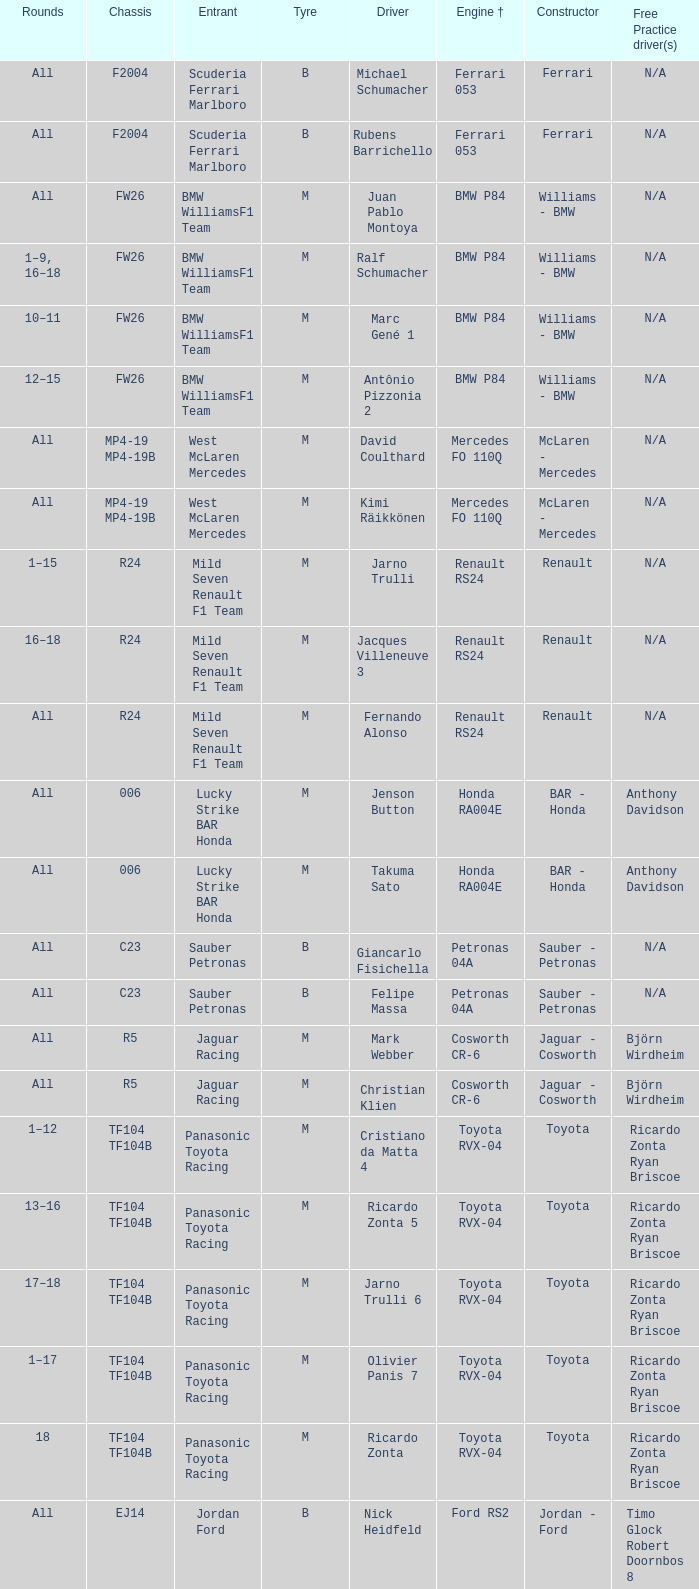Could you parse the entire table? {'header': ['Rounds', 'Chassis', 'Entrant', 'Tyre', 'Driver', 'Engine †', 'Constructor', 'Free Practice driver(s)'], 'rows': [['All', 'F2004', 'Scuderia Ferrari Marlboro', 'B', 'Michael Schumacher', 'Ferrari 053', 'Ferrari', 'N/A'], ['All', 'F2004', 'Scuderia Ferrari Marlboro', 'B', 'Rubens Barrichello', 'Ferrari 053', 'Ferrari', 'N/A'], ['All', 'FW26', 'BMW WilliamsF1 Team', 'M', 'Juan Pablo Montoya', 'BMW P84', 'Williams - BMW', 'N/A'], ['1–9, 16–18', 'FW26', 'BMW WilliamsF1 Team', 'M', 'Ralf Schumacher', 'BMW P84', 'Williams - BMW', 'N/A'], ['10–11', 'FW26', 'BMW WilliamsF1 Team', 'M', 'Marc Gené 1', 'BMW P84', 'Williams - BMW', 'N/A'], ['12–15', 'FW26', 'BMW WilliamsF1 Team', 'M', 'Antônio Pizzonia 2', 'BMW P84', 'Williams - BMW', 'N/A'], ['All', 'MP4-19 MP4-19B', 'West McLaren Mercedes', 'M', 'David Coulthard', 'Mercedes FO 110Q', 'McLaren - Mercedes', 'N/A'], ['All', 'MP4-19 MP4-19B', 'West McLaren Mercedes', 'M', 'Kimi Räikkönen', 'Mercedes FO 110Q', 'McLaren - Mercedes', 'N/A'], ['1–15', 'R24', 'Mild Seven Renault F1 Team', 'M', 'Jarno Trulli', 'Renault RS24', 'Renault', 'N/A'], ['16–18', 'R24', 'Mild Seven Renault F1 Team', 'M', 'Jacques Villeneuve 3', 'Renault RS24', 'Renault', 'N/A'], ['All', 'R24', 'Mild Seven Renault F1 Team', 'M', 'Fernando Alonso', 'Renault RS24', 'Renault', 'N/A'], ['All', '006', 'Lucky Strike BAR Honda', 'M', 'Jenson Button', 'Honda RA004E', 'BAR - Honda', 'Anthony Davidson'], ['All', '006', 'Lucky Strike BAR Honda', 'M', 'Takuma Sato', 'Honda RA004E', 'BAR - Honda', 'Anthony Davidson'], ['All', 'C23', 'Sauber Petronas', 'B', 'Giancarlo Fisichella', 'Petronas 04A', 'Sauber - Petronas', 'N/A'], ['All', 'C23', 'Sauber Petronas', 'B', 'Felipe Massa', 'Petronas 04A', 'Sauber - Petronas', 'N/A'], ['All', 'R5', 'Jaguar Racing', 'M', 'Mark Webber', 'Cosworth CR-6', 'Jaguar - Cosworth', 'Björn Wirdheim'], ['All', 'R5', 'Jaguar Racing', 'M', 'Christian Klien', 'Cosworth CR-6', 'Jaguar - Cosworth', 'Björn Wirdheim'], ['1–12', 'TF104 TF104B', 'Panasonic Toyota Racing', 'M', 'Cristiano da Matta 4', 'Toyota RVX-04', 'Toyota', 'Ricardo Zonta Ryan Briscoe'], ['13–16', 'TF104 TF104B', 'Panasonic Toyota Racing', 'M', 'Ricardo Zonta 5', 'Toyota RVX-04', 'Toyota', 'Ricardo Zonta Ryan Briscoe'], ['17–18', 'TF104 TF104B', 'Panasonic Toyota Racing', 'M', 'Jarno Trulli 6', 'Toyota RVX-04', 'Toyota', 'Ricardo Zonta Ryan Briscoe'], ['1–17', 'TF104 TF104B', 'Panasonic Toyota Racing', 'M', 'Olivier Panis 7', 'Toyota RVX-04', 'Toyota', 'Ricardo Zonta Ryan Briscoe'], ['18', 'TF104 TF104B', 'Panasonic Toyota Racing', 'M', 'Ricardo Zonta', 'Toyota RVX-04', 'Toyota', 'Ricardo Zonta Ryan Briscoe'], ['All', 'EJ14', 'Jordan Ford', 'B', 'Nick Heidfeld', 'Ford RS2', 'Jordan - Ford', 'Timo Glock Robert Doornbos 8'], ['1–7, 9–15', 'EJ14', 'Jordan Ford', 'B', 'Giorgio Pantano 9', 'Ford RS2', 'Jordan - Ford', 'Timo Glock Robert Doornbos 8'], ['8, 16–18', 'EJ14', 'Jordan Ford', 'B', 'Timo Glock 10', 'Ford RS2', 'Jordan - Ford', 'Timo Glock Robert Doornbos 8'], ['All', 'PS04B', 'Minardi Cosworth', 'B', 'Gianmaria Bruni', 'Cosworth CR-3 L', 'Minardi - Cosworth', 'Bas Leinders'], ['All', 'PS04B', 'Minardi Cosworth', 'B', 'Zsolt Baumgartner', 'Cosworth CR-3 L', 'Minardi - Cosworth', 'Bas Leinders']]} What kind of chassis does Ricardo Zonta have? TF104 TF104B. 